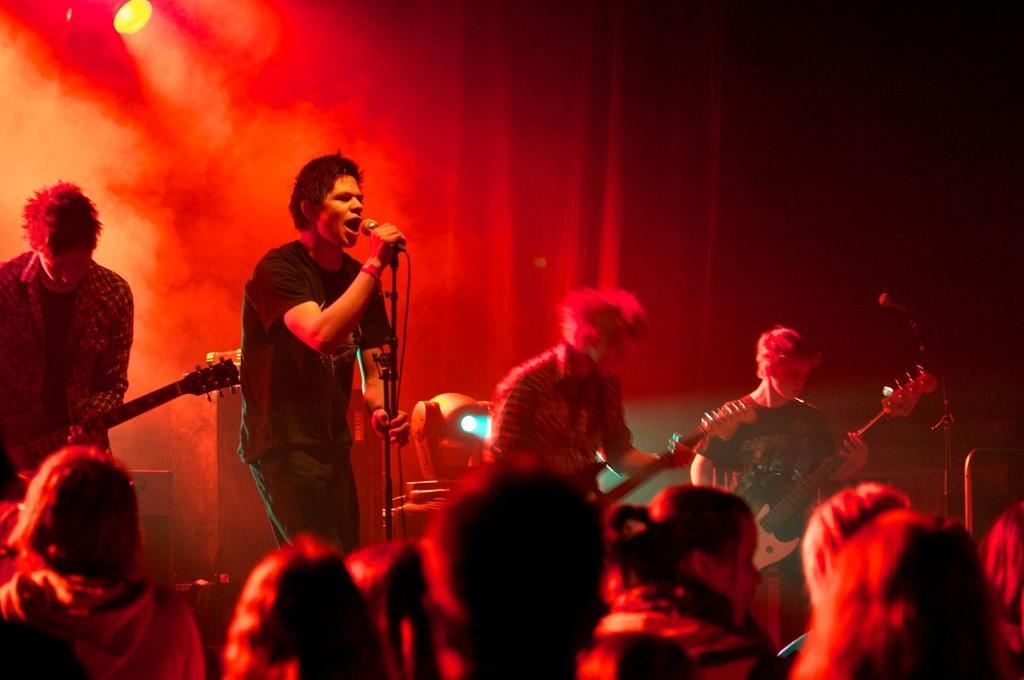How would you summarize this image in a sentence or two? In this image there is a person holding a mic is singing on the stage, beside the person there are three other persons playing guitar, in front of them there are audience, in the background of the image there is a curtain and a focus light. 